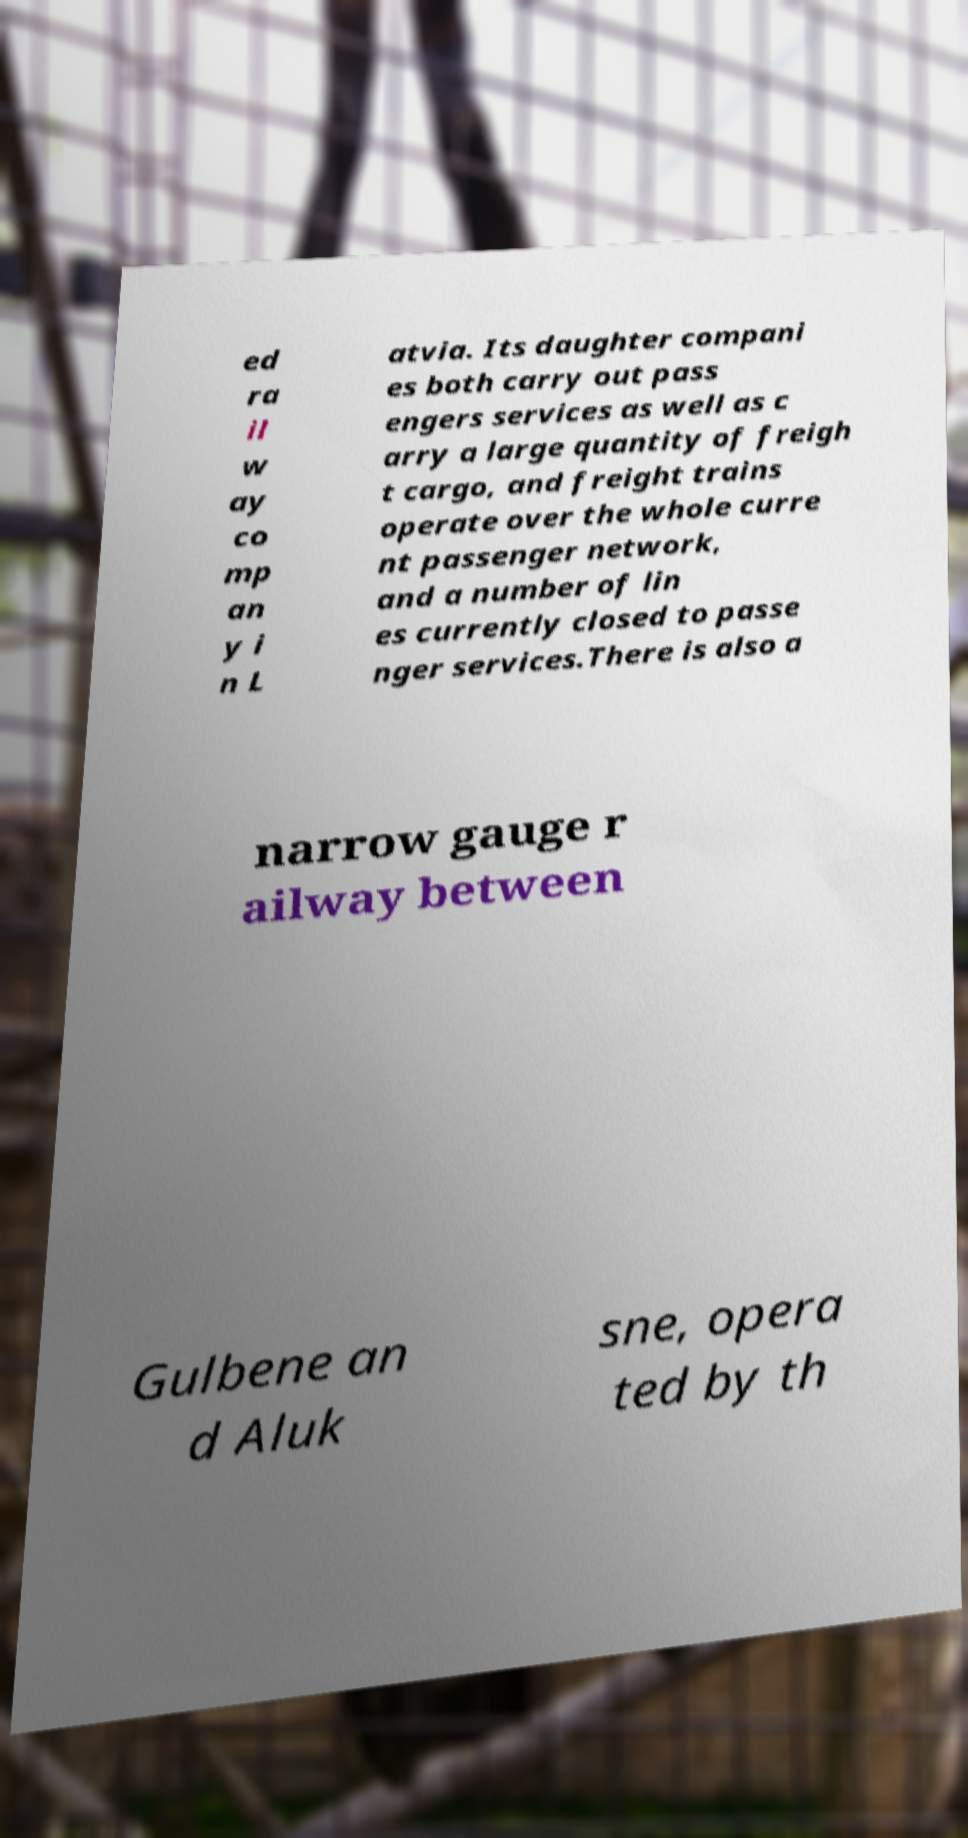Can you read and provide the text displayed in the image?This photo seems to have some interesting text. Can you extract and type it out for me? ed ra il w ay co mp an y i n L atvia. Its daughter compani es both carry out pass engers services as well as c arry a large quantity of freigh t cargo, and freight trains operate over the whole curre nt passenger network, and a number of lin es currently closed to passe nger services.There is also a narrow gauge r ailway between Gulbene an d Aluk sne, opera ted by th 